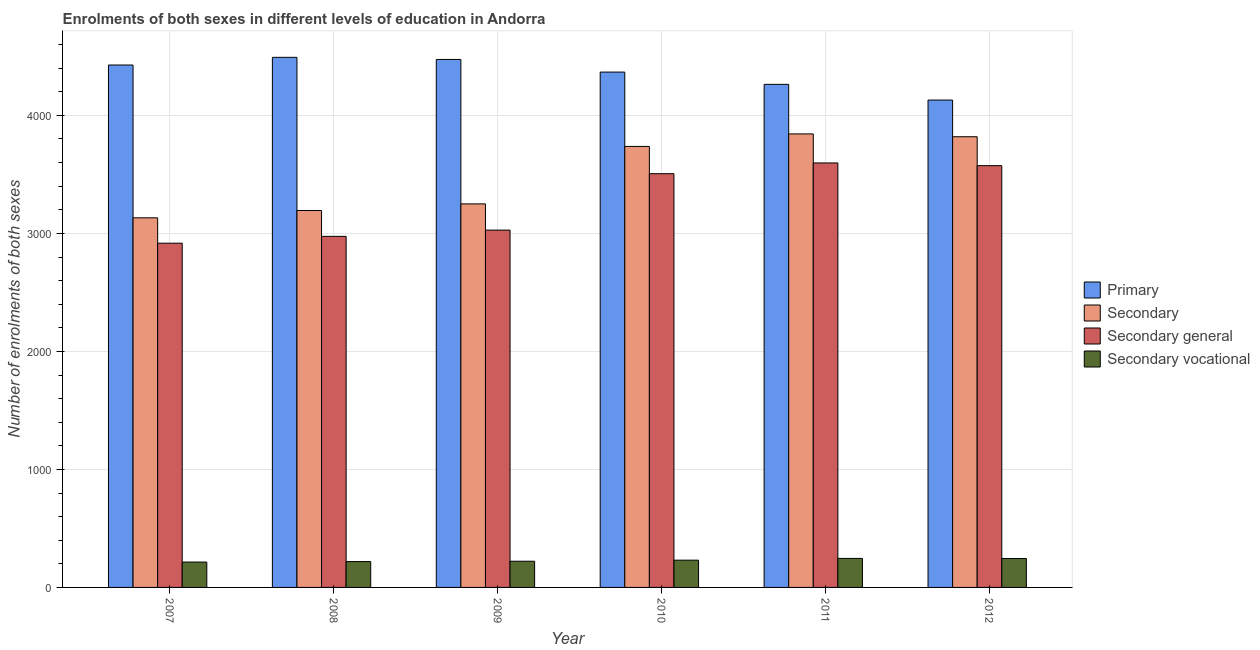Are the number of bars on each tick of the X-axis equal?
Give a very brief answer. Yes. How many bars are there on the 5th tick from the left?
Provide a succinct answer. 4. What is the number of enrolments in secondary vocational education in 2012?
Provide a succinct answer. 245. Across all years, what is the maximum number of enrolments in secondary vocational education?
Offer a very short reply. 246. Across all years, what is the minimum number of enrolments in secondary general education?
Offer a very short reply. 2917. In which year was the number of enrolments in primary education maximum?
Make the answer very short. 2008. In which year was the number of enrolments in primary education minimum?
Offer a very short reply. 2012. What is the total number of enrolments in secondary general education in the graph?
Your response must be concise. 1.96e+04. What is the difference between the number of enrolments in secondary vocational education in 2007 and that in 2008?
Your answer should be very brief. -4. What is the difference between the number of enrolments in secondary education in 2010 and the number of enrolments in secondary vocational education in 2007?
Your answer should be compact. 605. What is the average number of enrolments in primary education per year?
Your response must be concise. 4358.83. In the year 2012, what is the difference between the number of enrolments in secondary education and number of enrolments in secondary general education?
Keep it short and to the point. 0. In how many years, is the number of enrolments in secondary education greater than 4200?
Keep it short and to the point. 0. What is the ratio of the number of enrolments in primary education in 2007 to that in 2012?
Offer a terse response. 1.07. Is the number of enrolments in secondary education in 2008 less than that in 2012?
Your answer should be very brief. Yes. What is the difference between the highest and the lowest number of enrolments in secondary general education?
Offer a terse response. 680. Is the sum of the number of enrolments in secondary general education in 2008 and 2012 greater than the maximum number of enrolments in secondary education across all years?
Ensure brevity in your answer.  Yes. Is it the case that in every year, the sum of the number of enrolments in secondary vocational education and number of enrolments in primary education is greater than the sum of number of enrolments in secondary education and number of enrolments in secondary general education?
Give a very brief answer. No. What does the 4th bar from the left in 2008 represents?
Provide a short and direct response. Secondary vocational. What does the 1st bar from the right in 2009 represents?
Offer a very short reply. Secondary vocational. Is it the case that in every year, the sum of the number of enrolments in primary education and number of enrolments in secondary education is greater than the number of enrolments in secondary general education?
Ensure brevity in your answer.  Yes. How many bars are there?
Make the answer very short. 24. Does the graph contain any zero values?
Give a very brief answer. No. Does the graph contain grids?
Provide a succinct answer. Yes. Where does the legend appear in the graph?
Give a very brief answer. Center right. How many legend labels are there?
Give a very brief answer. 4. What is the title of the graph?
Provide a short and direct response. Enrolments of both sexes in different levels of education in Andorra. Does "Rule based governance" appear as one of the legend labels in the graph?
Give a very brief answer. No. What is the label or title of the Y-axis?
Your answer should be compact. Number of enrolments of both sexes. What is the Number of enrolments of both sexes of Primary in 2007?
Provide a succinct answer. 4427. What is the Number of enrolments of both sexes of Secondary in 2007?
Give a very brief answer. 3132. What is the Number of enrolments of both sexes of Secondary general in 2007?
Provide a short and direct response. 2917. What is the Number of enrolments of both sexes in Secondary vocational in 2007?
Ensure brevity in your answer.  215. What is the Number of enrolments of both sexes in Primary in 2008?
Give a very brief answer. 4492. What is the Number of enrolments of both sexes of Secondary in 2008?
Offer a terse response. 3194. What is the Number of enrolments of both sexes of Secondary general in 2008?
Your answer should be very brief. 2975. What is the Number of enrolments of both sexes of Secondary vocational in 2008?
Your answer should be very brief. 219. What is the Number of enrolments of both sexes in Primary in 2009?
Keep it short and to the point. 4474. What is the Number of enrolments of both sexes of Secondary in 2009?
Offer a terse response. 3250. What is the Number of enrolments of both sexes in Secondary general in 2009?
Ensure brevity in your answer.  3028. What is the Number of enrolments of both sexes in Secondary vocational in 2009?
Make the answer very short. 222. What is the Number of enrolments of both sexes in Primary in 2010?
Provide a succinct answer. 4367. What is the Number of enrolments of both sexes in Secondary in 2010?
Keep it short and to the point. 3737. What is the Number of enrolments of both sexes in Secondary general in 2010?
Ensure brevity in your answer.  3506. What is the Number of enrolments of both sexes of Secondary vocational in 2010?
Keep it short and to the point. 231. What is the Number of enrolments of both sexes in Primary in 2011?
Ensure brevity in your answer.  4263. What is the Number of enrolments of both sexes of Secondary in 2011?
Your answer should be very brief. 3843. What is the Number of enrolments of both sexes of Secondary general in 2011?
Keep it short and to the point. 3597. What is the Number of enrolments of both sexes of Secondary vocational in 2011?
Your response must be concise. 246. What is the Number of enrolments of both sexes in Primary in 2012?
Your answer should be compact. 4130. What is the Number of enrolments of both sexes in Secondary in 2012?
Give a very brief answer. 3819. What is the Number of enrolments of both sexes in Secondary general in 2012?
Offer a terse response. 3574. What is the Number of enrolments of both sexes in Secondary vocational in 2012?
Provide a short and direct response. 245. Across all years, what is the maximum Number of enrolments of both sexes of Primary?
Ensure brevity in your answer.  4492. Across all years, what is the maximum Number of enrolments of both sexes of Secondary?
Give a very brief answer. 3843. Across all years, what is the maximum Number of enrolments of both sexes of Secondary general?
Your answer should be very brief. 3597. Across all years, what is the maximum Number of enrolments of both sexes in Secondary vocational?
Ensure brevity in your answer.  246. Across all years, what is the minimum Number of enrolments of both sexes in Primary?
Provide a short and direct response. 4130. Across all years, what is the minimum Number of enrolments of both sexes of Secondary?
Your answer should be compact. 3132. Across all years, what is the minimum Number of enrolments of both sexes in Secondary general?
Ensure brevity in your answer.  2917. Across all years, what is the minimum Number of enrolments of both sexes in Secondary vocational?
Offer a very short reply. 215. What is the total Number of enrolments of both sexes in Primary in the graph?
Provide a short and direct response. 2.62e+04. What is the total Number of enrolments of both sexes in Secondary in the graph?
Give a very brief answer. 2.10e+04. What is the total Number of enrolments of both sexes of Secondary general in the graph?
Ensure brevity in your answer.  1.96e+04. What is the total Number of enrolments of both sexes in Secondary vocational in the graph?
Make the answer very short. 1378. What is the difference between the Number of enrolments of both sexes of Primary in 2007 and that in 2008?
Ensure brevity in your answer.  -65. What is the difference between the Number of enrolments of both sexes of Secondary in 2007 and that in 2008?
Make the answer very short. -62. What is the difference between the Number of enrolments of both sexes of Secondary general in 2007 and that in 2008?
Make the answer very short. -58. What is the difference between the Number of enrolments of both sexes in Primary in 2007 and that in 2009?
Provide a short and direct response. -47. What is the difference between the Number of enrolments of both sexes of Secondary in 2007 and that in 2009?
Offer a very short reply. -118. What is the difference between the Number of enrolments of both sexes of Secondary general in 2007 and that in 2009?
Offer a terse response. -111. What is the difference between the Number of enrolments of both sexes in Primary in 2007 and that in 2010?
Keep it short and to the point. 60. What is the difference between the Number of enrolments of both sexes in Secondary in 2007 and that in 2010?
Ensure brevity in your answer.  -605. What is the difference between the Number of enrolments of both sexes of Secondary general in 2007 and that in 2010?
Ensure brevity in your answer.  -589. What is the difference between the Number of enrolments of both sexes in Secondary vocational in 2007 and that in 2010?
Your answer should be compact. -16. What is the difference between the Number of enrolments of both sexes in Primary in 2007 and that in 2011?
Provide a short and direct response. 164. What is the difference between the Number of enrolments of both sexes in Secondary in 2007 and that in 2011?
Your answer should be very brief. -711. What is the difference between the Number of enrolments of both sexes of Secondary general in 2007 and that in 2011?
Your response must be concise. -680. What is the difference between the Number of enrolments of both sexes in Secondary vocational in 2007 and that in 2011?
Offer a terse response. -31. What is the difference between the Number of enrolments of both sexes of Primary in 2007 and that in 2012?
Offer a very short reply. 297. What is the difference between the Number of enrolments of both sexes in Secondary in 2007 and that in 2012?
Make the answer very short. -687. What is the difference between the Number of enrolments of both sexes of Secondary general in 2007 and that in 2012?
Your answer should be compact. -657. What is the difference between the Number of enrolments of both sexes of Secondary vocational in 2007 and that in 2012?
Make the answer very short. -30. What is the difference between the Number of enrolments of both sexes in Primary in 2008 and that in 2009?
Offer a terse response. 18. What is the difference between the Number of enrolments of both sexes in Secondary in 2008 and that in 2009?
Make the answer very short. -56. What is the difference between the Number of enrolments of both sexes in Secondary general in 2008 and that in 2009?
Provide a succinct answer. -53. What is the difference between the Number of enrolments of both sexes in Primary in 2008 and that in 2010?
Your response must be concise. 125. What is the difference between the Number of enrolments of both sexes in Secondary in 2008 and that in 2010?
Provide a succinct answer. -543. What is the difference between the Number of enrolments of both sexes of Secondary general in 2008 and that in 2010?
Provide a succinct answer. -531. What is the difference between the Number of enrolments of both sexes in Primary in 2008 and that in 2011?
Keep it short and to the point. 229. What is the difference between the Number of enrolments of both sexes in Secondary in 2008 and that in 2011?
Provide a succinct answer. -649. What is the difference between the Number of enrolments of both sexes in Secondary general in 2008 and that in 2011?
Provide a succinct answer. -622. What is the difference between the Number of enrolments of both sexes of Primary in 2008 and that in 2012?
Provide a short and direct response. 362. What is the difference between the Number of enrolments of both sexes of Secondary in 2008 and that in 2012?
Give a very brief answer. -625. What is the difference between the Number of enrolments of both sexes in Secondary general in 2008 and that in 2012?
Offer a very short reply. -599. What is the difference between the Number of enrolments of both sexes of Primary in 2009 and that in 2010?
Provide a short and direct response. 107. What is the difference between the Number of enrolments of both sexes of Secondary in 2009 and that in 2010?
Make the answer very short. -487. What is the difference between the Number of enrolments of both sexes of Secondary general in 2009 and that in 2010?
Provide a succinct answer. -478. What is the difference between the Number of enrolments of both sexes in Primary in 2009 and that in 2011?
Provide a succinct answer. 211. What is the difference between the Number of enrolments of both sexes in Secondary in 2009 and that in 2011?
Offer a very short reply. -593. What is the difference between the Number of enrolments of both sexes in Secondary general in 2009 and that in 2011?
Your answer should be very brief. -569. What is the difference between the Number of enrolments of both sexes of Secondary vocational in 2009 and that in 2011?
Ensure brevity in your answer.  -24. What is the difference between the Number of enrolments of both sexes of Primary in 2009 and that in 2012?
Make the answer very short. 344. What is the difference between the Number of enrolments of both sexes in Secondary in 2009 and that in 2012?
Provide a short and direct response. -569. What is the difference between the Number of enrolments of both sexes of Secondary general in 2009 and that in 2012?
Ensure brevity in your answer.  -546. What is the difference between the Number of enrolments of both sexes of Secondary vocational in 2009 and that in 2012?
Your answer should be very brief. -23. What is the difference between the Number of enrolments of both sexes in Primary in 2010 and that in 2011?
Make the answer very short. 104. What is the difference between the Number of enrolments of both sexes in Secondary in 2010 and that in 2011?
Provide a succinct answer. -106. What is the difference between the Number of enrolments of both sexes of Secondary general in 2010 and that in 2011?
Provide a short and direct response. -91. What is the difference between the Number of enrolments of both sexes of Secondary vocational in 2010 and that in 2011?
Your answer should be compact. -15. What is the difference between the Number of enrolments of both sexes in Primary in 2010 and that in 2012?
Ensure brevity in your answer.  237. What is the difference between the Number of enrolments of both sexes of Secondary in 2010 and that in 2012?
Provide a succinct answer. -82. What is the difference between the Number of enrolments of both sexes of Secondary general in 2010 and that in 2012?
Your answer should be compact. -68. What is the difference between the Number of enrolments of both sexes of Secondary vocational in 2010 and that in 2012?
Your answer should be very brief. -14. What is the difference between the Number of enrolments of both sexes of Primary in 2011 and that in 2012?
Provide a short and direct response. 133. What is the difference between the Number of enrolments of both sexes of Secondary vocational in 2011 and that in 2012?
Provide a succinct answer. 1. What is the difference between the Number of enrolments of both sexes of Primary in 2007 and the Number of enrolments of both sexes of Secondary in 2008?
Give a very brief answer. 1233. What is the difference between the Number of enrolments of both sexes in Primary in 2007 and the Number of enrolments of both sexes in Secondary general in 2008?
Your answer should be very brief. 1452. What is the difference between the Number of enrolments of both sexes in Primary in 2007 and the Number of enrolments of both sexes in Secondary vocational in 2008?
Offer a very short reply. 4208. What is the difference between the Number of enrolments of both sexes in Secondary in 2007 and the Number of enrolments of both sexes in Secondary general in 2008?
Keep it short and to the point. 157. What is the difference between the Number of enrolments of both sexes in Secondary in 2007 and the Number of enrolments of both sexes in Secondary vocational in 2008?
Offer a terse response. 2913. What is the difference between the Number of enrolments of both sexes of Secondary general in 2007 and the Number of enrolments of both sexes of Secondary vocational in 2008?
Give a very brief answer. 2698. What is the difference between the Number of enrolments of both sexes of Primary in 2007 and the Number of enrolments of both sexes of Secondary in 2009?
Provide a short and direct response. 1177. What is the difference between the Number of enrolments of both sexes in Primary in 2007 and the Number of enrolments of both sexes in Secondary general in 2009?
Offer a very short reply. 1399. What is the difference between the Number of enrolments of both sexes of Primary in 2007 and the Number of enrolments of both sexes of Secondary vocational in 2009?
Provide a succinct answer. 4205. What is the difference between the Number of enrolments of both sexes in Secondary in 2007 and the Number of enrolments of both sexes in Secondary general in 2009?
Offer a very short reply. 104. What is the difference between the Number of enrolments of both sexes of Secondary in 2007 and the Number of enrolments of both sexes of Secondary vocational in 2009?
Provide a succinct answer. 2910. What is the difference between the Number of enrolments of both sexes in Secondary general in 2007 and the Number of enrolments of both sexes in Secondary vocational in 2009?
Your answer should be compact. 2695. What is the difference between the Number of enrolments of both sexes in Primary in 2007 and the Number of enrolments of both sexes in Secondary in 2010?
Keep it short and to the point. 690. What is the difference between the Number of enrolments of both sexes of Primary in 2007 and the Number of enrolments of both sexes of Secondary general in 2010?
Keep it short and to the point. 921. What is the difference between the Number of enrolments of both sexes in Primary in 2007 and the Number of enrolments of both sexes in Secondary vocational in 2010?
Your answer should be very brief. 4196. What is the difference between the Number of enrolments of both sexes of Secondary in 2007 and the Number of enrolments of both sexes of Secondary general in 2010?
Provide a succinct answer. -374. What is the difference between the Number of enrolments of both sexes in Secondary in 2007 and the Number of enrolments of both sexes in Secondary vocational in 2010?
Keep it short and to the point. 2901. What is the difference between the Number of enrolments of both sexes in Secondary general in 2007 and the Number of enrolments of both sexes in Secondary vocational in 2010?
Give a very brief answer. 2686. What is the difference between the Number of enrolments of both sexes of Primary in 2007 and the Number of enrolments of both sexes of Secondary in 2011?
Offer a terse response. 584. What is the difference between the Number of enrolments of both sexes of Primary in 2007 and the Number of enrolments of both sexes of Secondary general in 2011?
Your response must be concise. 830. What is the difference between the Number of enrolments of both sexes of Primary in 2007 and the Number of enrolments of both sexes of Secondary vocational in 2011?
Make the answer very short. 4181. What is the difference between the Number of enrolments of both sexes in Secondary in 2007 and the Number of enrolments of both sexes in Secondary general in 2011?
Give a very brief answer. -465. What is the difference between the Number of enrolments of both sexes of Secondary in 2007 and the Number of enrolments of both sexes of Secondary vocational in 2011?
Your response must be concise. 2886. What is the difference between the Number of enrolments of both sexes in Secondary general in 2007 and the Number of enrolments of both sexes in Secondary vocational in 2011?
Make the answer very short. 2671. What is the difference between the Number of enrolments of both sexes in Primary in 2007 and the Number of enrolments of both sexes in Secondary in 2012?
Keep it short and to the point. 608. What is the difference between the Number of enrolments of both sexes of Primary in 2007 and the Number of enrolments of both sexes of Secondary general in 2012?
Give a very brief answer. 853. What is the difference between the Number of enrolments of both sexes in Primary in 2007 and the Number of enrolments of both sexes in Secondary vocational in 2012?
Your answer should be very brief. 4182. What is the difference between the Number of enrolments of both sexes in Secondary in 2007 and the Number of enrolments of both sexes in Secondary general in 2012?
Offer a very short reply. -442. What is the difference between the Number of enrolments of both sexes of Secondary in 2007 and the Number of enrolments of both sexes of Secondary vocational in 2012?
Provide a short and direct response. 2887. What is the difference between the Number of enrolments of both sexes in Secondary general in 2007 and the Number of enrolments of both sexes in Secondary vocational in 2012?
Offer a terse response. 2672. What is the difference between the Number of enrolments of both sexes in Primary in 2008 and the Number of enrolments of both sexes in Secondary in 2009?
Your answer should be very brief. 1242. What is the difference between the Number of enrolments of both sexes of Primary in 2008 and the Number of enrolments of both sexes of Secondary general in 2009?
Make the answer very short. 1464. What is the difference between the Number of enrolments of both sexes in Primary in 2008 and the Number of enrolments of both sexes in Secondary vocational in 2009?
Your response must be concise. 4270. What is the difference between the Number of enrolments of both sexes of Secondary in 2008 and the Number of enrolments of both sexes of Secondary general in 2009?
Your answer should be very brief. 166. What is the difference between the Number of enrolments of both sexes in Secondary in 2008 and the Number of enrolments of both sexes in Secondary vocational in 2009?
Offer a terse response. 2972. What is the difference between the Number of enrolments of both sexes in Secondary general in 2008 and the Number of enrolments of both sexes in Secondary vocational in 2009?
Your response must be concise. 2753. What is the difference between the Number of enrolments of both sexes in Primary in 2008 and the Number of enrolments of both sexes in Secondary in 2010?
Offer a terse response. 755. What is the difference between the Number of enrolments of both sexes in Primary in 2008 and the Number of enrolments of both sexes in Secondary general in 2010?
Give a very brief answer. 986. What is the difference between the Number of enrolments of both sexes in Primary in 2008 and the Number of enrolments of both sexes in Secondary vocational in 2010?
Your answer should be very brief. 4261. What is the difference between the Number of enrolments of both sexes of Secondary in 2008 and the Number of enrolments of both sexes of Secondary general in 2010?
Your response must be concise. -312. What is the difference between the Number of enrolments of both sexes of Secondary in 2008 and the Number of enrolments of both sexes of Secondary vocational in 2010?
Ensure brevity in your answer.  2963. What is the difference between the Number of enrolments of both sexes in Secondary general in 2008 and the Number of enrolments of both sexes in Secondary vocational in 2010?
Provide a short and direct response. 2744. What is the difference between the Number of enrolments of both sexes in Primary in 2008 and the Number of enrolments of both sexes in Secondary in 2011?
Your answer should be very brief. 649. What is the difference between the Number of enrolments of both sexes in Primary in 2008 and the Number of enrolments of both sexes in Secondary general in 2011?
Give a very brief answer. 895. What is the difference between the Number of enrolments of both sexes in Primary in 2008 and the Number of enrolments of both sexes in Secondary vocational in 2011?
Give a very brief answer. 4246. What is the difference between the Number of enrolments of both sexes of Secondary in 2008 and the Number of enrolments of both sexes of Secondary general in 2011?
Make the answer very short. -403. What is the difference between the Number of enrolments of both sexes in Secondary in 2008 and the Number of enrolments of both sexes in Secondary vocational in 2011?
Your answer should be very brief. 2948. What is the difference between the Number of enrolments of both sexes in Secondary general in 2008 and the Number of enrolments of both sexes in Secondary vocational in 2011?
Your answer should be very brief. 2729. What is the difference between the Number of enrolments of both sexes of Primary in 2008 and the Number of enrolments of both sexes of Secondary in 2012?
Offer a very short reply. 673. What is the difference between the Number of enrolments of both sexes of Primary in 2008 and the Number of enrolments of both sexes of Secondary general in 2012?
Provide a succinct answer. 918. What is the difference between the Number of enrolments of both sexes in Primary in 2008 and the Number of enrolments of both sexes in Secondary vocational in 2012?
Provide a short and direct response. 4247. What is the difference between the Number of enrolments of both sexes of Secondary in 2008 and the Number of enrolments of both sexes of Secondary general in 2012?
Make the answer very short. -380. What is the difference between the Number of enrolments of both sexes in Secondary in 2008 and the Number of enrolments of both sexes in Secondary vocational in 2012?
Ensure brevity in your answer.  2949. What is the difference between the Number of enrolments of both sexes of Secondary general in 2008 and the Number of enrolments of both sexes of Secondary vocational in 2012?
Offer a terse response. 2730. What is the difference between the Number of enrolments of both sexes in Primary in 2009 and the Number of enrolments of both sexes in Secondary in 2010?
Make the answer very short. 737. What is the difference between the Number of enrolments of both sexes of Primary in 2009 and the Number of enrolments of both sexes of Secondary general in 2010?
Your answer should be compact. 968. What is the difference between the Number of enrolments of both sexes of Primary in 2009 and the Number of enrolments of both sexes of Secondary vocational in 2010?
Your answer should be compact. 4243. What is the difference between the Number of enrolments of both sexes in Secondary in 2009 and the Number of enrolments of both sexes in Secondary general in 2010?
Give a very brief answer. -256. What is the difference between the Number of enrolments of both sexes in Secondary in 2009 and the Number of enrolments of both sexes in Secondary vocational in 2010?
Give a very brief answer. 3019. What is the difference between the Number of enrolments of both sexes of Secondary general in 2009 and the Number of enrolments of both sexes of Secondary vocational in 2010?
Your answer should be compact. 2797. What is the difference between the Number of enrolments of both sexes in Primary in 2009 and the Number of enrolments of both sexes in Secondary in 2011?
Make the answer very short. 631. What is the difference between the Number of enrolments of both sexes of Primary in 2009 and the Number of enrolments of both sexes of Secondary general in 2011?
Offer a very short reply. 877. What is the difference between the Number of enrolments of both sexes of Primary in 2009 and the Number of enrolments of both sexes of Secondary vocational in 2011?
Your answer should be very brief. 4228. What is the difference between the Number of enrolments of both sexes in Secondary in 2009 and the Number of enrolments of both sexes in Secondary general in 2011?
Keep it short and to the point. -347. What is the difference between the Number of enrolments of both sexes of Secondary in 2009 and the Number of enrolments of both sexes of Secondary vocational in 2011?
Your answer should be compact. 3004. What is the difference between the Number of enrolments of both sexes of Secondary general in 2009 and the Number of enrolments of both sexes of Secondary vocational in 2011?
Your response must be concise. 2782. What is the difference between the Number of enrolments of both sexes in Primary in 2009 and the Number of enrolments of both sexes in Secondary in 2012?
Offer a terse response. 655. What is the difference between the Number of enrolments of both sexes in Primary in 2009 and the Number of enrolments of both sexes in Secondary general in 2012?
Ensure brevity in your answer.  900. What is the difference between the Number of enrolments of both sexes in Primary in 2009 and the Number of enrolments of both sexes in Secondary vocational in 2012?
Your response must be concise. 4229. What is the difference between the Number of enrolments of both sexes in Secondary in 2009 and the Number of enrolments of both sexes in Secondary general in 2012?
Your response must be concise. -324. What is the difference between the Number of enrolments of both sexes of Secondary in 2009 and the Number of enrolments of both sexes of Secondary vocational in 2012?
Give a very brief answer. 3005. What is the difference between the Number of enrolments of both sexes of Secondary general in 2009 and the Number of enrolments of both sexes of Secondary vocational in 2012?
Ensure brevity in your answer.  2783. What is the difference between the Number of enrolments of both sexes of Primary in 2010 and the Number of enrolments of both sexes of Secondary in 2011?
Your answer should be very brief. 524. What is the difference between the Number of enrolments of both sexes of Primary in 2010 and the Number of enrolments of both sexes of Secondary general in 2011?
Give a very brief answer. 770. What is the difference between the Number of enrolments of both sexes in Primary in 2010 and the Number of enrolments of both sexes in Secondary vocational in 2011?
Provide a succinct answer. 4121. What is the difference between the Number of enrolments of both sexes in Secondary in 2010 and the Number of enrolments of both sexes in Secondary general in 2011?
Make the answer very short. 140. What is the difference between the Number of enrolments of both sexes of Secondary in 2010 and the Number of enrolments of both sexes of Secondary vocational in 2011?
Keep it short and to the point. 3491. What is the difference between the Number of enrolments of both sexes of Secondary general in 2010 and the Number of enrolments of both sexes of Secondary vocational in 2011?
Your answer should be compact. 3260. What is the difference between the Number of enrolments of both sexes of Primary in 2010 and the Number of enrolments of both sexes of Secondary in 2012?
Offer a terse response. 548. What is the difference between the Number of enrolments of both sexes of Primary in 2010 and the Number of enrolments of both sexes of Secondary general in 2012?
Ensure brevity in your answer.  793. What is the difference between the Number of enrolments of both sexes of Primary in 2010 and the Number of enrolments of both sexes of Secondary vocational in 2012?
Your answer should be compact. 4122. What is the difference between the Number of enrolments of both sexes of Secondary in 2010 and the Number of enrolments of both sexes of Secondary general in 2012?
Provide a succinct answer. 163. What is the difference between the Number of enrolments of both sexes of Secondary in 2010 and the Number of enrolments of both sexes of Secondary vocational in 2012?
Your answer should be very brief. 3492. What is the difference between the Number of enrolments of both sexes of Secondary general in 2010 and the Number of enrolments of both sexes of Secondary vocational in 2012?
Ensure brevity in your answer.  3261. What is the difference between the Number of enrolments of both sexes of Primary in 2011 and the Number of enrolments of both sexes of Secondary in 2012?
Make the answer very short. 444. What is the difference between the Number of enrolments of both sexes of Primary in 2011 and the Number of enrolments of both sexes of Secondary general in 2012?
Give a very brief answer. 689. What is the difference between the Number of enrolments of both sexes of Primary in 2011 and the Number of enrolments of both sexes of Secondary vocational in 2012?
Your answer should be compact. 4018. What is the difference between the Number of enrolments of both sexes in Secondary in 2011 and the Number of enrolments of both sexes in Secondary general in 2012?
Provide a succinct answer. 269. What is the difference between the Number of enrolments of both sexes of Secondary in 2011 and the Number of enrolments of both sexes of Secondary vocational in 2012?
Your answer should be compact. 3598. What is the difference between the Number of enrolments of both sexes of Secondary general in 2011 and the Number of enrolments of both sexes of Secondary vocational in 2012?
Keep it short and to the point. 3352. What is the average Number of enrolments of both sexes of Primary per year?
Your answer should be compact. 4358.83. What is the average Number of enrolments of both sexes in Secondary per year?
Your answer should be compact. 3495.83. What is the average Number of enrolments of both sexes of Secondary general per year?
Your response must be concise. 3266.17. What is the average Number of enrolments of both sexes in Secondary vocational per year?
Make the answer very short. 229.67. In the year 2007, what is the difference between the Number of enrolments of both sexes of Primary and Number of enrolments of both sexes of Secondary?
Give a very brief answer. 1295. In the year 2007, what is the difference between the Number of enrolments of both sexes in Primary and Number of enrolments of both sexes in Secondary general?
Offer a terse response. 1510. In the year 2007, what is the difference between the Number of enrolments of both sexes of Primary and Number of enrolments of both sexes of Secondary vocational?
Provide a short and direct response. 4212. In the year 2007, what is the difference between the Number of enrolments of both sexes in Secondary and Number of enrolments of both sexes in Secondary general?
Your response must be concise. 215. In the year 2007, what is the difference between the Number of enrolments of both sexes of Secondary and Number of enrolments of both sexes of Secondary vocational?
Keep it short and to the point. 2917. In the year 2007, what is the difference between the Number of enrolments of both sexes of Secondary general and Number of enrolments of both sexes of Secondary vocational?
Give a very brief answer. 2702. In the year 2008, what is the difference between the Number of enrolments of both sexes in Primary and Number of enrolments of both sexes in Secondary?
Keep it short and to the point. 1298. In the year 2008, what is the difference between the Number of enrolments of both sexes in Primary and Number of enrolments of both sexes in Secondary general?
Ensure brevity in your answer.  1517. In the year 2008, what is the difference between the Number of enrolments of both sexes of Primary and Number of enrolments of both sexes of Secondary vocational?
Make the answer very short. 4273. In the year 2008, what is the difference between the Number of enrolments of both sexes of Secondary and Number of enrolments of both sexes of Secondary general?
Offer a very short reply. 219. In the year 2008, what is the difference between the Number of enrolments of both sexes in Secondary and Number of enrolments of both sexes in Secondary vocational?
Provide a succinct answer. 2975. In the year 2008, what is the difference between the Number of enrolments of both sexes of Secondary general and Number of enrolments of both sexes of Secondary vocational?
Make the answer very short. 2756. In the year 2009, what is the difference between the Number of enrolments of both sexes in Primary and Number of enrolments of both sexes in Secondary?
Provide a succinct answer. 1224. In the year 2009, what is the difference between the Number of enrolments of both sexes in Primary and Number of enrolments of both sexes in Secondary general?
Keep it short and to the point. 1446. In the year 2009, what is the difference between the Number of enrolments of both sexes of Primary and Number of enrolments of both sexes of Secondary vocational?
Your answer should be compact. 4252. In the year 2009, what is the difference between the Number of enrolments of both sexes in Secondary and Number of enrolments of both sexes in Secondary general?
Ensure brevity in your answer.  222. In the year 2009, what is the difference between the Number of enrolments of both sexes in Secondary and Number of enrolments of both sexes in Secondary vocational?
Your answer should be compact. 3028. In the year 2009, what is the difference between the Number of enrolments of both sexes in Secondary general and Number of enrolments of both sexes in Secondary vocational?
Your response must be concise. 2806. In the year 2010, what is the difference between the Number of enrolments of both sexes of Primary and Number of enrolments of both sexes of Secondary?
Provide a succinct answer. 630. In the year 2010, what is the difference between the Number of enrolments of both sexes of Primary and Number of enrolments of both sexes of Secondary general?
Offer a very short reply. 861. In the year 2010, what is the difference between the Number of enrolments of both sexes in Primary and Number of enrolments of both sexes in Secondary vocational?
Provide a succinct answer. 4136. In the year 2010, what is the difference between the Number of enrolments of both sexes in Secondary and Number of enrolments of both sexes in Secondary general?
Provide a succinct answer. 231. In the year 2010, what is the difference between the Number of enrolments of both sexes in Secondary and Number of enrolments of both sexes in Secondary vocational?
Your answer should be compact. 3506. In the year 2010, what is the difference between the Number of enrolments of both sexes of Secondary general and Number of enrolments of both sexes of Secondary vocational?
Offer a terse response. 3275. In the year 2011, what is the difference between the Number of enrolments of both sexes in Primary and Number of enrolments of both sexes in Secondary?
Give a very brief answer. 420. In the year 2011, what is the difference between the Number of enrolments of both sexes in Primary and Number of enrolments of both sexes in Secondary general?
Give a very brief answer. 666. In the year 2011, what is the difference between the Number of enrolments of both sexes in Primary and Number of enrolments of both sexes in Secondary vocational?
Provide a short and direct response. 4017. In the year 2011, what is the difference between the Number of enrolments of both sexes of Secondary and Number of enrolments of both sexes of Secondary general?
Offer a terse response. 246. In the year 2011, what is the difference between the Number of enrolments of both sexes in Secondary and Number of enrolments of both sexes in Secondary vocational?
Your answer should be very brief. 3597. In the year 2011, what is the difference between the Number of enrolments of both sexes in Secondary general and Number of enrolments of both sexes in Secondary vocational?
Make the answer very short. 3351. In the year 2012, what is the difference between the Number of enrolments of both sexes in Primary and Number of enrolments of both sexes in Secondary?
Provide a short and direct response. 311. In the year 2012, what is the difference between the Number of enrolments of both sexes of Primary and Number of enrolments of both sexes of Secondary general?
Your answer should be very brief. 556. In the year 2012, what is the difference between the Number of enrolments of both sexes of Primary and Number of enrolments of both sexes of Secondary vocational?
Your response must be concise. 3885. In the year 2012, what is the difference between the Number of enrolments of both sexes of Secondary and Number of enrolments of both sexes of Secondary general?
Offer a very short reply. 245. In the year 2012, what is the difference between the Number of enrolments of both sexes of Secondary and Number of enrolments of both sexes of Secondary vocational?
Give a very brief answer. 3574. In the year 2012, what is the difference between the Number of enrolments of both sexes of Secondary general and Number of enrolments of both sexes of Secondary vocational?
Your response must be concise. 3329. What is the ratio of the Number of enrolments of both sexes of Primary in 2007 to that in 2008?
Your answer should be compact. 0.99. What is the ratio of the Number of enrolments of both sexes in Secondary in 2007 to that in 2008?
Offer a terse response. 0.98. What is the ratio of the Number of enrolments of both sexes of Secondary general in 2007 to that in 2008?
Ensure brevity in your answer.  0.98. What is the ratio of the Number of enrolments of both sexes of Secondary vocational in 2007 to that in 2008?
Make the answer very short. 0.98. What is the ratio of the Number of enrolments of both sexes in Secondary in 2007 to that in 2009?
Your answer should be very brief. 0.96. What is the ratio of the Number of enrolments of both sexes in Secondary general in 2007 to that in 2009?
Your answer should be compact. 0.96. What is the ratio of the Number of enrolments of both sexes in Secondary vocational in 2007 to that in 2009?
Your answer should be compact. 0.97. What is the ratio of the Number of enrolments of both sexes in Primary in 2007 to that in 2010?
Provide a short and direct response. 1.01. What is the ratio of the Number of enrolments of both sexes of Secondary in 2007 to that in 2010?
Your answer should be very brief. 0.84. What is the ratio of the Number of enrolments of both sexes in Secondary general in 2007 to that in 2010?
Your answer should be very brief. 0.83. What is the ratio of the Number of enrolments of both sexes in Secondary vocational in 2007 to that in 2010?
Offer a very short reply. 0.93. What is the ratio of the Number of enrolments of both sexes of Primary in 2007 to that in 2011?
Offer a very short reply. 1.04. What is the ratio of the Number of enrolments of both sexes in Secondary in 2007 to that in 2011?
Keep it short and to the point. 0.81. What is the ratio of the Number of enrolments of both sexes in Secondary general in 2007 to that in 2011?
Ensure brevity in your answer.  0.81. What is the ratio of the Number of enrolments of both sexes in Secondary vocational in 2007 to that in 2011?
Offer a very short reply. 0.87. What is the ratio of the Number of enrolments of both sexes of Primary in 2007 to that in 2012?
Offer a terse response. 1.07. What is the ratio of the Number of enrolments of both sexes of Secondary in 2007 to that in 2012?
Offer a terse response. 0.82. What is the ratio of the Number of enrolments of both sexes in Secondary general in 2007 to that in 2012?
Your response must be concise. 0.82. What is the ratio of the Number of enrolments of both sexes in Secondary vocational in 2007 to that in 2012?
Keep it short and to the point. 0.88. What is the ratio of the Number of enrolments of both sexes of Secondary in 2008 to that in 2009?
Your response must be concise. 0.98. What is the ratio of the Number of enrolments of both sexes of Secondary general in 2008 to that in 2009?
Your answer should be compact. 0.98. What is the ratio of the Number of enrolments of both sexes in Secondary vocational in 2008 to that in 2009?
Give a very brief answer. 0.99. What is the ratio of the Number of enrolments of both sexes of Primary in 2008 to that in 2010?
Offer a terse response. 1.03. What is the ratio of the Number of enrolments of both sexes of Secondary in 2008 to that in 2010?
Ensure brevity in your answer.  0.85. What is the ratio of the Number of enrolments of both sexes of Secondary general in 2008 to that in 2010?
Your answer should be very brief. 0.85. What is the ratio of the Number of enrolments of both sexes in Secondary vocational in 2008 to that in 2010?
Make the answer very short. 0.95. What is the ratio of the Number of enrolments of both sexes in Primary in 2008 to that in 2011?
Your answer should be compact. 1.05. What is the ratio of the Number of enrolments of both sexes in Secondary in 2008 to that in 2011?
Give a very brief answer. 0.83. What is the ratio of the Number of enrolments of both sexes of Secondary general in 2008 to that in 2011?
Ensure brevity in your answer.  0.83. What is the ratio of the Number of enrolments of both sexes of Secondary vocational in 2008 to that in 2011?
Your answer should be very brief. 0.89. What is the ratio of the Number of enrolments of both sexes of Primary in 2008 to that in 2012?
Offer a terse response. 1.09. What is the ratio of the Number of enrolments of both sexes in Secondary in 2008 to that in 2012?
Provide a short and direct response. 0.84. What is the ratio of the Number of enrolments of both sexes of Secondary general in 2008 to that in 2012?
Your answer should be very brief. 0.83. What is the ratio of the Number of enrolments of both sexes of Secondary vocational in 2008 to that in 2012?
Your answer should be very brief. 0.89. What is the ratio of the Number of enrolments of both sexes in Primary in 2009 to that in 2010?
Provide a succinct answer. 1.02. What is the ratio of the Number of enrolments of both sexes of Secondary in 2009 to that in 2010?
Your answer should be compact. 0.87. What is the ratio of the Number of enrolments of both sexes in Secondary general in 2009 to that in 2010?
Your response must be concise. 0.86. What is the ratio of the Number of enrolments of both sexes of Secondary vocational in 2009 to that in 2010?
Offer a terse response. 0.96. What is the ratio of the Number of enrolments of both sexes of Primary in 2009 to that in 2011?
Offer a terse response. 1.05. What is the ratio of the Number of enrolments of both sexes of Secondary in 2009 to that in 2011?
Make the answer very short. 0.85. What is the ratio of the Number of enrolments of both sexes of Secondary general in 2009 to that in 2011?
Your response must be concise. 0.84. What is the ratio of the Number of enrolments of both sexes in Secondary vocational in 2009 to that in 2011?
Your answer should be compact. 0.9. What is the ratio of the Number of enrolments of both sexes in Primary in 2009 to that in 2012?
Keep it short and to the point. 1.08. What is the ratio of the Number of enrolments of both sexes of Secondary in 2009 to that in 2012?
Provide a succinct answer. 0.85. What is the ratio of the Number of enrolments of both sexes in Secondary general in 2009 to that in 2012?
Your answer should be compact. 0.85. What is the ratio of the Number of enrolments of both sexes of Secondary vocational in 2009 to that in 2012?
Your response must be concise. 0.91. What is the ratio of the Number of enrolments of both sexes in Primary in 2010 to that in 2011?
Your response must be concise. 1.02. What is the ratio of the Number of enrolments of both sexes in Secondary in 2010 to that in 2011?
Offer a terse response. 0.97. What is the ratio of the Number of enrolments of both sexes in Secondary general in 2010 to that in 2011?
Offer a very short reply. 0.97. What is the ratio of the Number of enrolments of both sexes in Secondary vocational in 2010 to that in 2011?
Your response must be concise. 0.94. What is the ratio of the Number of enrolments of both sexes in Primary in 2010 to that in 2012?
Your response must be concise. 1.06. What is the ratio of the Number of enrolments of both sexes in Secondary in 2010 to that in 2012?
Offer a terse response. 0.98. What is the ratio of the Number of enrolments of both sexes in Secondary vocational in 2010 to that in 2012?
Your response must be concise. 0.94. What is the ratio of the Number of enrolments of both sexes of Primary in 2011 to that in 2012?
Give a very brief answer. 1.03. What is the ratio of the Number of enrolments of both sexes of Secondary in 2011 to that in 2012?
Offer a very short reply. 1.01. What is the ratio of the Number of enrolments of both sexes in Secondary general in 2011 to that in 2012?
Ensure brevity in your answer.  1.01. What is the difference between the highest and the second highest Number of enrolments of both sexes in Secondary general?
Provide a succinct answer. 23. What is the difference between the highest and the second highest Number of enrolments of both sexes in Secondary vocational?
Offer a very short reply. 1. What is the difference between the highest and the lowest Number of enrolments of both sexes of Primary?
Your answer should be compact. 362. What is the difference between the highest and the lowest Number of enrolments of both sexes of Secondary?
Keep it short and to the point. 711. What is the difference between the highest and the lowest Number of enrolments of both sexes in Secondary general?
Your answer should be very brief. 680. What is the difference between the highest and the lowest Number of enrolments of both sexes in Secondary vocational?
Ensure brevity in your answer.  31. 